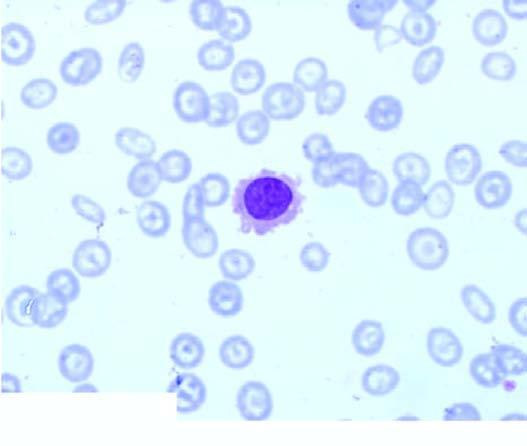does peripheral blood show presence of a leukaemic cells with hairy cytoplasmic projections?
Answer the question using a single word or phrase. Yes 